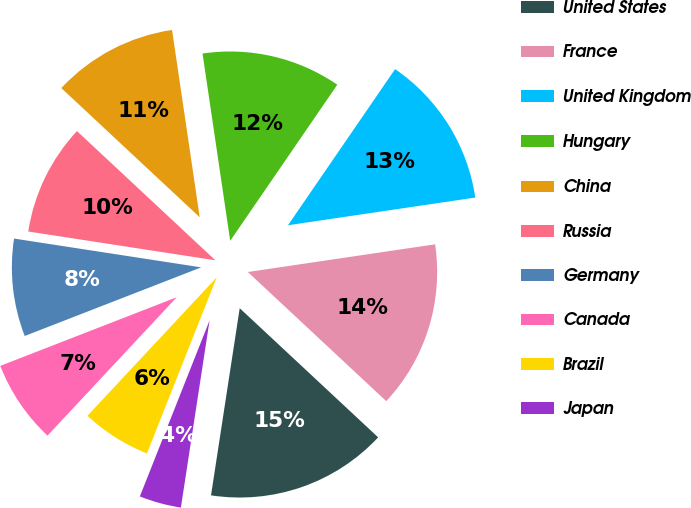Convert chart. <chart><loc_0><loc_0><loc_500><loc_500><pie_chart><fcel>United States<fcel>France<fcel>United Kingdom<fcel>Hungary<fcel>China<fcel>Russia<fcel>Germany<fcel>Canada<fcel>Brazil<fcel>Japan<nl><fcel>15.47%<fcel>14.28%<fcel>13.09%<fcel>11.9%<fcel>10.71%<fcel>9.52%<fcel>8.33%<fcel>7.14%<fcel>5.95%<fcel>3.58%<nl></chart> 